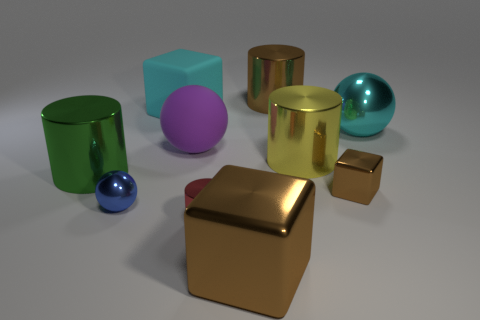What material is the big cylinder that is the same color as the tiny cube?
Your answer should be compact. Metal. Is the small cube the same color as the big shiny cube?
Offer a very short reply. Yes. What number of matte objects are large purple things or red things?
Offer a terse response. 1. Is there a small cylinder that has the same material as the big green object?
Provide a short and direct response. Yes. What is the material of the big green thing?
Provide a succinct answer. Metal. What shape is the big brown metallic thing that is left of the brown thing behind the metal cylinder to the left of the red cylinder?
Make the answer very short. Cube. Is the number of green objects in front of the large cyan block greater than the number of blue metal cylinders?
Ensure brevity in your answer.  Yes. There is a large yellow metal object; is its shape the same as the brown thing that is behind the big green cylinder?
Your answer should be very brief. Yes. What is the shape of the small metal object that is the same color as the big metal block?
Make the answer very short. Cube. What number of red metal objects are in front of the big brown metallic thing behind the cyan object that is on the left side of the big brown shiny cylinder?
Offer a very short reply. 1. 